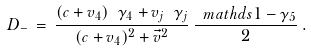Convert formula to latex. <formula><loc_0><loc_0><loc_500><loc_500>D _ { - } \, = \, \frac { ( c + v _ { 4 } ) \ \gamma _ { 4 } + v _ { j } \ \gamma _ { j } } { ( c + v _ { 4 } ) ^ { 2 } + \vec { v } ^ { 2 } } \, \frac { \ m a t h d s { 1 } - \gamma _ { 5 } } { 2 } \, .</formula> 